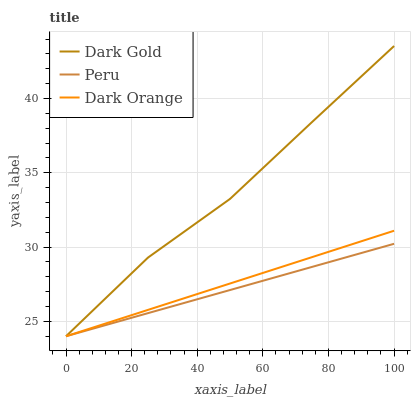Does Peru have the minimum area under the curve?
Answer yes or no. Yes. Does Dark Gold have the maximum area under the curve?
Answer yes or no. Yes. Does Dark Gold have the minimum area under the curve?
Answer yes or no. No. Does Peru have the maximum area under the curve?
Answer yes or no. No. Is Dark Orange the smoothest?
Answer yes or no. Yes. Is Dark Gold the roughest?
Answer yes or no. Yes. Is Peru the smoothest?
Answer yes or no. No. Is Peru the roughest?
Answer yes or no. No. Does Dark Orange have the lowest value?
Answer yes or no. Yes. Does Dark Gold have the highest value?
Answer yes or no. Yes. Does Peru have the highest value?
Answer yes or no. No. Does Peru intersect Dark Orange?
Answer yes or no. Yes. Is Peru less than Dark Orange?
Answer yes or no. No. Is Peru greater than Dark Orange?
Answer yes or no. No. 